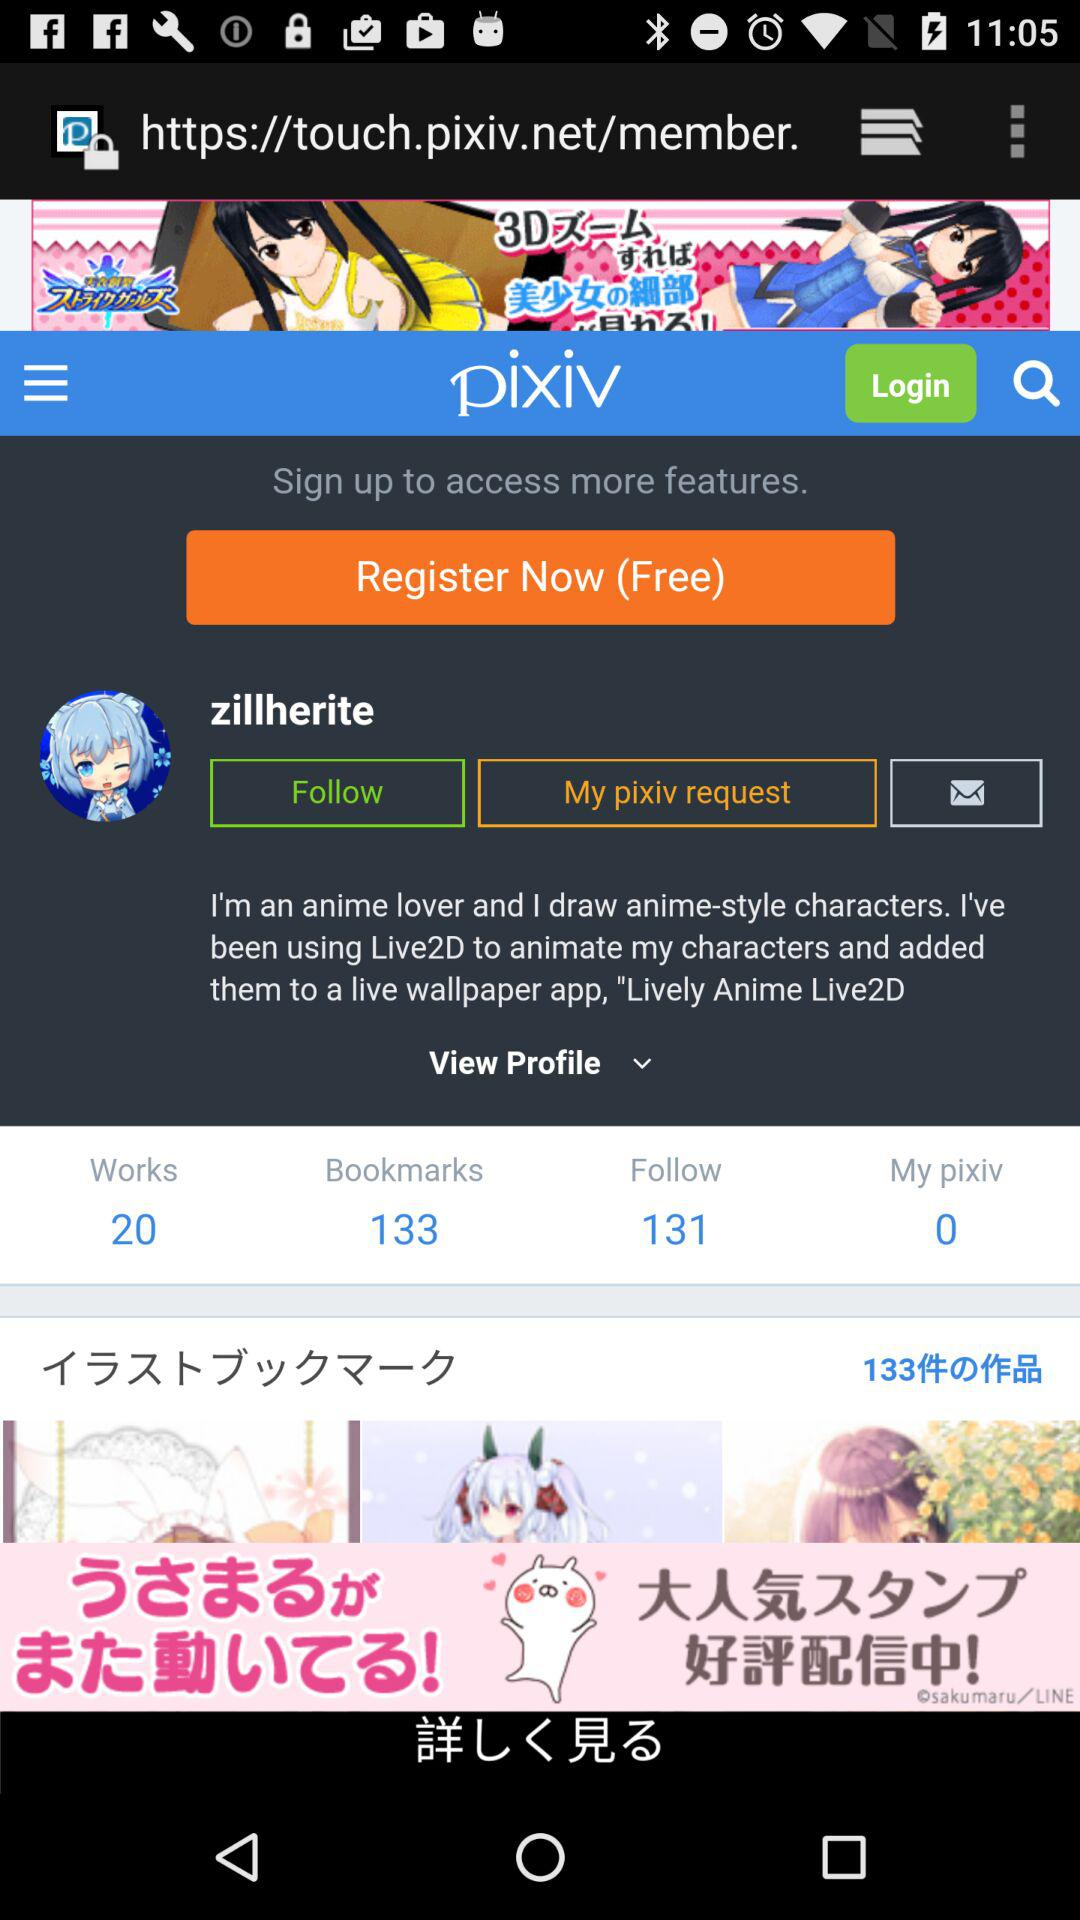What is the name of the application? The name of the application is "pixiv". 